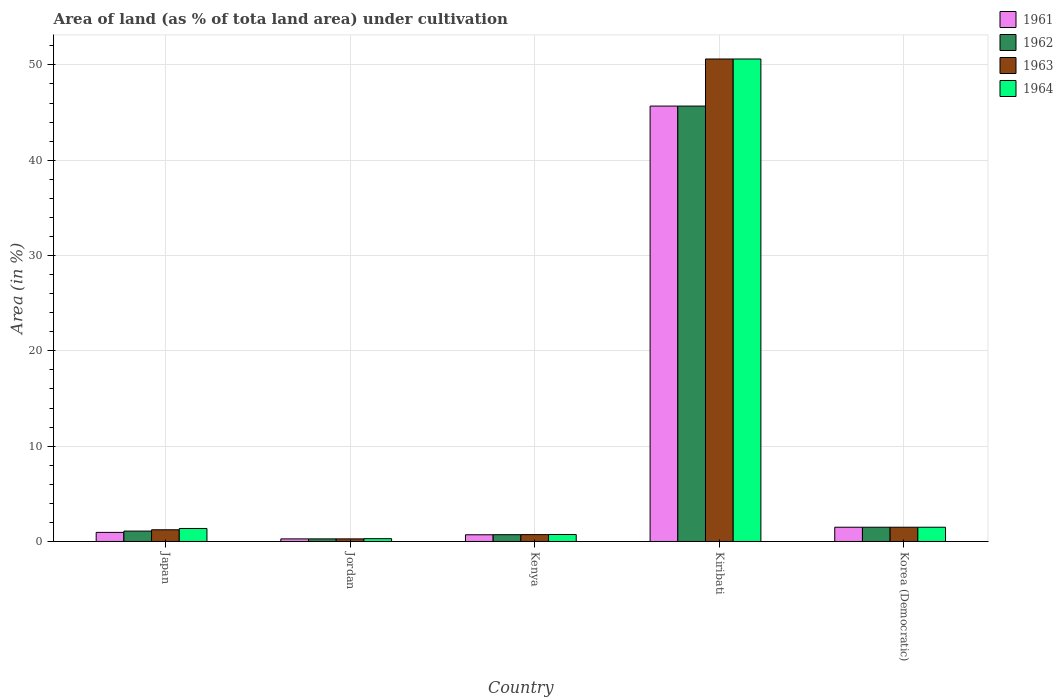How many groups of bars are there?
Your answer should be compact. 5. How many bars are there on the 1st tick from the left?
Your answer should be compact. 4. How many bars are there on the 1st tick from the right?
Your response must be concise. 4. What is the label of the 2nd group of bars from the left?
Ensure brevity in your answer.  Jordan. What is the percentage of land under cultivation in 1961 in Kiribati?
Provide a succinct answer. 45.68. Across all countries, what is the maximum percentage of land under cultivation in 1962?
Ensure brevity in your answer.  45.68. Across all countries, what is the minimum percentage of land under cultivation in 1961?
Keep it short and to the point. 0.27. In which country was the percentage of land under cultivation in 1961 maximum?
Provide a short and direct response. Kiribati. In which country was the percentage of land under cultivation in 1963 minimum?
Make the answer very short. Jordan. What is the total percentage of land under cultivation in 1963 in the graph?
Ensure brevity in your answer.  54.33. What is the difference between the percentage of land under cultivation in 1964 in Kenya and that in Kiribati?
Ensure brevity in your answer.  -49.89. What is the difference between the percentage of land under cultivation in 1961 in Jordan and the percentage of land under cultivation in 1962 in Japan?
Your response must be concise. -0.82. What is the average percentage of land under cultivation in 1964 per country?
Your response must be concise. 10.9. What is the difference between the percentage of land under cultivation of/in 1963 and percentage of land under cultivation of/in 1964 in Japan?
Ensure brevity in your answer.  -0.14. What is the ratio of the percentage of land under cultivation in 1963 in Japan to that in Korea (Democratic)?
Your answer should be compact. 0.82. Is the percentage of land under cultivation in 1961 in Kenya less than that in Korea (Democratic)?
Your answer should be very brief. Yes. Is the difference between the percentage of land under cultivation in 1963 in Japan and Kenya greater than the difference between the percentage of land under cultivation in 1964 in Japan and Kenya?
Your response must be concise. No. What is the difference between the highest and the second highest percentage of land under cultivation in 1961?
Your answer should be compact. -0.54. What is the difference between the highest and the lowest percentage of land under cultivation in 1963?
Your answer should be very brief. 50.35. In how many countries, is the percentage of land under cultivation in 1964 greater than the average percentage of land under cultivation in 1964 taken over all countries?
Ensure brevity in your answer.  1. Is it the case that in every country, the sum of the percentage of land under cultivation in 1964 and percentage of land under cultivation in 1962 is greater than the sum of percentage of land under cultivation in 1963 and percentage of land under cultivation in 1961?
Provide a succinct answer. No. What does the 4th bar from the left in Japan represents?
Provide a succinct answer. 1964. What does the 2nd bar from the right in Jordan represents?
Offer a very short reply. 1963. How many countries are there in the graph?
Offer a terse response. 5. Are the values on the major ticks of Y-axis written in scientific E-notation?
Your answer should be compact. No. Does the graph contain any zero values?
Offer a very short reply. No. Where does the legend appear in the graph?
Provide a short and direct response. Top right. How are the legend labels stacked?
Keep it short and to the point. Vertical. What is the title of the graph?
Keep it short and to the point. Area of land (as % of tota land area) under cultivation. What is the label or title of the X-axis?
Make the answer very short. Country. What is the label or title of the Y-axis?
Ensure brevity in your answer.  Area (in %). What is the Area (in %) in 1961 in Japan?
Your response must be concise. 0.95. What is the Area (in %) in 1962 in Japan?
Ensure brevity in your answer.  1.09. What is the Area (in %) in 1963 in Japan?
Keep it short and to the point. 1.23. What is the Area (in %) of 1964 in Japan?
Your answer should be compact. 1.36. What is the Area (in %) of 1961 in Jordan?
Provide a short and direct response. 0.27. What is the Area (in %) in 1962 in Jordan?
Ensure brevity in your answer.  0.27. What is the Area (in %) of 1963 in Jordan?
Provide a short and direct response. 0.27. What is the Area (in %) of 1964 in Jordan?
Your answer should be very brief. 0.29. What is the Area (in %) in 1961 in Kenya?
Your answer should be very brief. 0.7. What is the Area (in %) in 1962 in Kenya?
Provide a short and direct response. 0.71. What is the Area (in %) in 1963 in Kenya?
Your response must be concise. 0.72. What is the Area (in %) in 1964 in Kenya?
Your response must be concise. 0.73. What is the Area (in %) in 1961 in Kiribati?
Keep it short and to the point. 45.68. What is the Area (in %) in 1962 in Kiribati?
Offer a very short reply. 45.68. What is the Area (in %) of 1963 in Kiribati?
Provide a succinct answer. 50.62. What is the Area (in %) of 1964 in Kiribati?
Provide a succinct answer. 50.62. What is the Area (in %) of 1961 in Korea (Democratic)?
Ensure brevity in your answer.  1.49. What is the Area (in %) of 1962 in Korea (Democratic)?
Make the answer very short. 1.49. What is the Area (in %) of 1963 in Korea (Democratic)?
Keep it short and to the point. 1.49. What is the Area (in %) in 1964 in Korea (Democratic)?
Provide a short and direct response. 1.49. Across all countries, what is the maximum Area (in %) in 1961?
Provide a short and direct response. 45.68. Across all countries, what is the maximum Area (in %) in 1962?
Give a very brief answer. 45.68. Across all countries, what is the maximum Area (in %) of 1963?
Your response must be concise. 50.62. Across all countries, what is the maximum Area (in %) of 1964?
Provide a succinct answer. 50.62. Across all countries, what is the minimum Area (in %) of 1961?
Keep it short and to the point. 0.27. Across all countries, what is the minimum Area (in %) in 1962?
Offer a terse response. 0.27. Across all countries, what is the minimum Area (in %) of 1963?
Your answer should be compact. 0.27. Across all countries, what is the minimum Area (in %) in 1964?
Your response must be concise. 0.29. What is the total Area (in %) of 1961 in the graph?
Give a very brief answer. 49.1. What is the total Area (in %) of 1962 in the graph?
Provide a succinct answer. 49.25. What is the total Area (in %) in 1963 in the graph?
Offer a terse response. 54.33. What is the total Area (in %) of 1964 in the graph?
Keep it short and to the point. 54.5. What is the difference between the Area (in %) of 1961 in Japan and that in Jordan?
Offer a very short reply. 0.68. What is the difference between the Area (in %) in 1962 in Japan and that in Jordan?
Make the answer very short. 0.82. What is the difference between the Area (in %) of 1963 in Japan and that in Jordan?
Offer a very short reply. 0.96. What is the difference between the Area (in %) of 1964 in Japan and that in Jordan?
Provide a succinct answer. 1.07. What is the difference between the Area (in %) in 1961 in Japan and that in Kenya?
Give a very brief answer. 0.25. What is the difference between the Area (in %) in 1962 in Japan and that in Kenya?
Your answer should be compact. 0.38. What is the difference between the Area (in %) in 1963 in Japan and that in Kenya?
Offer a very short reply. 0.51. What is the difference between the Area (in %) of 1964 in Japan and that in Kenya?
Give a very brief answer. 0.63. What is the difference between the Area (in %) in 1961 in Japan and that in Kiribati?
Make the answer very short. -44.72. What is the difference between the Area (in %) in 1962 in Japan and that in Kiribati?
Offer a very short reply. -44.59. What is the difference between the Area (in %) in 1963 in Japan and that in Kiribati?
Make the answer very short. -49.39. What is the difference between the Area (in %) of 1964 in Japan and that in Kiribati?
Ensure brevity in your answer.  -49.25. What is the difference between the Area (in %) in 1961 in Japan and that in Korea (Democratic)?
Make the answer very short. -0.54. What is the difference between the Area (in %) in 1962 in Japan and that in Korea (Democratic)?
Make the answer very short. -0.4. What is the difference between the Area (in %) in 1963 in Japan and that in Korea (Democratic)?
Your answer should be compact. -0.27. What is the difference between the Area (in %) of 1964 in Japan and that in Korea (Democratic)?
Offer a terse response. -0.13. What is the difference between the Area (in %) of 1961 in Jordan and that in Kenya?
Give a very brief answer. -0.43. What is the difference between the Area (in %) in 1962 in Jordan and that in Kenya?
Provide a succinct answer. -0.44. What is the difference between the Area (in %) of 1963 in Jordan and that in Kenya?
Make the answer very short. -0.45. What is the difference between the Area (in %) of 1964 in Jordan and that in Kenya?
Your answer should be compact. -0.43. What is the difference between the Area (in %) of 1961 in Jordan and that in Kiribati?
Make the answer very short. -45.41. What is the difference between the Area (in %) in 1962 in Jordan and that in Kiribati?
Your answer should be compact. -45.41. What is the difference between the Area (in %) in 1963 in Jordan and that in Kiribati?
Give a very brief answer. -50.35. What is the difference between the Area (in %) of 1964 in Jordan and that in Kiribati?
Offer a terse response. -50.32. What is the difference between the Area (in %) in 1961 in Jordan and that in Korea (Democratic)?
Keep it short and to the point. -1.22. What is the difference between the Area (in %) in 1962 in Jordan and that in Korea (Democratic)?
Provide a short and direct response. -1.22. What is the difference between the Area (in %) of 1963 in Jordan and that in Korea (Democratic)?
Provide a short and direct response. -1.22. What is the difference between the Area (in %) in 1964 in Jordan and that in Korea (Democratic)?
Give a very brief answer. -1.2. What is the difference between the Area (in %) of 1961 in Kenya and that in Kiribati?
Offer a very short reply. -44.98. What is the difference between the Area (in %) of 1962 in Kenya and that in Kiribati?
Provide a short and direct response. -44.97. What is the difference between the Area (in %) of 1963 in Kenya and that in Kiribati?
Offer a terse response. -49.9. What is the difference between the Area (in %) of 1964 in Kenya and that in Kiribati?
Make the answer very short. -49.89. What is the difference between the Area (in %) of 1961 in Kenya and that in Korea (Democratic)?
Your answer should be compact. -0.79. What is the difference between the Area (in %) in 1962 in Kenya and that in Korea (Democratic)?
Your answer should be compact. -0.78. What is the difference between the Area (in %) in 1963 in Kenya and that in Korea (Democratic)?
Ensure brevity in your answer.  -0.77. What is the difference between the Area (in %) of 1964 in Kenya and that in Korea (Democratic)?
Provide a short and direct response. -0.77. What is the difference between the Area (in %) of 1961 in Kiribati and that in Korea (Democratic)?
Provide a succinct answer. 44.18. What is the difference between the Area (in %) of 1962 in Kiribati and that in Korea (Democratic)?
Ensure brevity in your answer.  44.18. What is the difference between the Area (in %) in 1963 in Kiribati and that in Korea (Democratic)?
Your answer should be compact. 49.12. What is the difference between the Area (in %) in 1964 in Kiribati and that in Korea (Democratic)?
Your answer should be very brief. 49.12. What is the difference between the Area (in %) in 1961 in Japan and the Area (in %) in 1962 in Jordan?
Offer a very short reply. 0.68. What is the difference between the Area (in %) of 1961 in Japan and the Area (in %) of 1963 in Jordan?
Make the answer very short. 0.68. What is the difference between the Area (in %) in 1961 in Japan and the Area (in %) in 1964 in Jordan?
Give a very brief answer. 0.66. What is the difference between the Area (in %) of 1962 in Japan and the Area (in %) of 1963 in Jordan?
Keep it short and to the point. 0.82. What is the difference between the Area (in %) in 1962 in Japan and the Area (in %) in 1964 in Jordan?
Give a very brief answer. 0.8. What is the difference between the Area (in %) of 1963 in Japan and the Area (in %) of 1964 in Jordan?
Your answer should be very brief. 0.93. What is the difference between the Area (in %) of 1961 in Japan and the Area (in %) of 1962 in Kenya?
Offer a terse response. 0.24. What is the difference between the Area (in %) in 1961 in Japan and the Area (in %) in 1963 in Kenya?
Provide a succinct answer. 0.23. What is the difference between the Area (in %) of 1961 in Japan and the Area (in %) of 1964 in Kenya?
Your answer should be compact. 0.23. What is the difference between the Area (in %) in 1962 in Japan and the Area (in %) in 1963 in Kenya?
Your answer should be very brief. 0.37. What is the difference between the Area (in %) in 1962 in Japan and the Area (in %) in 1964 in Kenya?
Provide a succinct answer. 0.36. What is the difference between the Area (in %) in 1963 in Japan and the Area (in %) in 1964 in Kenya?
Provide a succinct answer. 0.5. What is the difference between the Area (in %) in 1961 in Japan and the Area (in %) in 1962 in Kiribati?
Ensure brevity in your answer.  -44.72. What is the difference between the Area (in %) of 1961 in Japan and the Area (in %) of 1963 in Kiribati?
Provide a short and direct response. -49.66. What is the difference between the Area (in %) of 1961 in Japan and the Area (in %) of 1964 in Kiribati?
Give a very brief answer. -49.66. What is the difference between the Area (in %) in 1962 in Japan and the Area (in %) in 1963 in Kiribati?
Your answer should be very brief. -49.53. What is the difference between the Area (in %) in 1962 in Japan and the Area (in %) in 1964 in Kiribati?
Your answer should be compact. -49.53. What is the difference between the Area (in %) in 1963 in Japan and the Area (in %) in 1964 in Kiribati?
Offer a terse response. -49.39. What is the difference between the Area (in %) of 1961 in Japan and the Area (in %) of 1962 in Korea (Democratic)?
Make the answer very short. -0.54. What is the difference between the Area (in %) in 1961 in Japan and the Area (in %) in 1963 in Korea (Democratic)?
Your response must be concise. -0.54. What is the difference between the Area (in %) of 1961 in Japan and the Area (in %) of 1964 in Korea (Democratic)?
Offer a terse response. -0.54. What is the difference between the Area (in %) of 1962 in Japan and the Area (in %) of 1963 in Korea (Democratic)?
Keep it short and to the point. -0.4. What is the difference between the Area (in %) of 1962 in Japan and the Area (in %) of 1964 in Korea (Democratic)?
Give a very brief answer. -0.4. What is the difference between the Area (in %) in 1963 in Japan and the Area (in %) in 1964 in Korea (Democratic)?
Ensure brevity in your answer.  -0.27. What is the difference between the Area (in %) in 1961 in Jordan and the Area (in %) in 1962 in Kenya?
Offer a terse response. -0.44. What is the difference between the Area (in %) in 1961 in Jordan and the Area (in %) in 1963 in Kenya?
Provide a short and direct response. -0.45. What is the difference between the Area (in %) in 1961 in Jordan and the Area (in %) in 1964 in Kenya?
Provide a short and direct response. -0.46. What is the difference between the Area (in %) of 1962 in Jordan and the Area (in %) of 1963 in Kenya?
Keep it short and to the point. -0.45. What is the difference between the Area (in %) in 1962 in Jordan and the Area (in %) in 1964 in Kenya?
Provide a short and direct response. -0.46. What is the difference between the Area (in %) in 1963 in Jordan and the Area (in %) in 1964 in Kenya?
Your answer should be compact. -0.46. What is the difference between the Area (in %) of 1961 in Jordan and the Area (in %) of 1962 in Kiribati?
Make the answer very short. -45.41. What is the difference between the Area (in %) of 1961 in Jordan and the Area (in %) of 1963 in Kiribati?
Your response must be concise. -50.35. What is the difference between the Area (in %) of 1961 in Jordan and the Area (in %) of 1964 in Kiribati?
Offer a terse response. -50.35. What is the difference between the Area (in %) of 1962 in Jordan and the Area (in %) of 1963 in Kiribati?
Offer a very short reply. -50.35. What is the difference between the Area (in %) in 1962 in Jordan and the Area (in %) in 1964 in Kiribati?
Provide a succinct answer. -50.35. What is the difference between the Area (in %) in 1963 in Jordan and the Area (in %) in 1964 in Kiribati?
Your answer should be very brief. -50.35. What is the difference between the Area (in %) of 1961 in Jordan and the Area (in %) of 1962 in Korea (Democratic)?
Offer a terse response. -1.22. What is the difference between the Area (in %) in 1961 in Jordan and the Area (in %) in 1963 in Korea (Democratic)?
Your answer should be very brief. -1.22. What is the difference between the Area (in %) in 1961 in Jordan and the Area (in %) in 1964 in Korea (Democratic)?
Provide a succinct answer. -1.22. What is the difference between the Area (in %) of 1962 in Jordan and the Area (in %) of 1963 in Korea (Democratic)?
Give a very brief answer. -1.22. What is the difference between the Area (in %) of 1962 in Jordan and the Area (in %) of 1964 in Korea (Democratic)?
Give a very brief answer. -1.22. What is the difference between the Area (in %) in 1963 in Jordan and the Area (in %) in 1964 in Korea (Democratic)?
Offer a very short reply. -1.22. What is the difference between the Area (in %) of 1961 in Kenya and the Area (in %) of 1962 in Kiribati?
Offer a very short reply. -44.98. What is the difference between the Area (in %) of 1961 in Kenya and the Area (in %) of 1963 in Kiribati?
Your answer should be very brief. -49.91. What is the difference between the Area (in %) in 1961 in Kenya and the Area (in %) in 1964 in Kiribati?
Give a very brief answer. -49.91. What is the difference between the Area (in %) in 1962 in Kenya and the Area (in %) in 1963 in Kiribati?
Your answer should be compact. -49.91. What is the difference between the Area (in %) of 1962 in Kenya and the Area (in %) of 1964 in Kiribati?
Your answer should be compact. -49.91. What is the difference between the Area (in %) of 1963 in Kenya and the Area (in %) of 1964 in Kiribati?
Keep it short and to the point. -49.9. What is the difference between the Area (in %) of 1961 in Kenya and the Area (in %) of 1962 in Korea (Democratic)?
Give a very brief answer. -0.79. What is the difference between the Area (in %) of 1961 in Kenya and the Area (in %) of 1963 in Korea (Democratic)?
Offer a very short reply. -0.79. What is the difference between the Area (in %) of 1961 in Kenya and the Area (in %) of 1964 in Korea (Democratic)?
Your response must be concise. -0.79. What is the difference between the Area (in %) of 1962 in Kenya and the Area (in %) of 1963 in Korea (Democratic)?
Your answer should be very brief. -0.78. What is the difference between the Area (in %) of 1962 in Kenya and the Area (in %) of 1964 in Korea (Democratic)?
Your answer should be very brief. -0.78. What is the difference between the Area (in %) in 1963 in Kenya and the Area (in %) in 1964 in Korea (Democratic)?
Provide a short and direct response. -0.77. What is the difference between the Area (in %) of 1961 in Kiribati and the Area (in %) of 1962 in Korea (Democratic)?
Keep it short and to the point. 44.18. What is the difference between the Area (in %) in 1961 in Kiribati and the Area (in %) in 1963 in Korea (Democratic)?
Give a very brief answer. 44.18. What is the difference between the Area (in %) of 1961 in Kiribati and the Area (in %) of 1964 in Korea (Democratic)?
Your answer should be very brief. 44.18. What is the difference between the Area (in %) in 1962 in Kiribati and the Area (in %) in 1963 in Korea (Democratic)?
Give a very brief answer. 44.18. What is the difference between the Area (in %) of 1962 in Kiribati and the Area (in %) of 1964 in Korea (Democratic)?
Offer a terse response. 44.18. What is the difference between the Area (in %) in 1963 in Kiribati and the Area (in %) in 1964 in Korea (Democratic)?
Provide a short and direct response. 49.12. What is the average Area (in %) in 1961 per country?
Ensure brevity in your answer.  9.82. What is the average Area (in %) in 1962 per country?
Provide a succinct answer. 9.85. What is the average Area (in %) in 1963 per country?
Your answer should be compact. 10.87. What is the average Area (in %) in 1964 per country?
Ensure brevity in your answer.  10.9. What is the difference between the Area (in %) in 1961 and Area (in %) in 1962 in Japan?
Make the answer very short. -0.14. What is the difference between the Area (in %) in 1961 and Area (in %) in 1963 in Japan?
Keep it short and to the point. -0.27. What is the difference between the Area (in %) of 1961 and Area (in %) of 1964 in Japan?
Keep it short and to the point. -0.41. What is the difference between the Area (in %) in 1962 and Area (in %) in 1963 in Japan?
Ensure brevity in your answer.  -0.14. What is the difference between the Area (in %) of 1962 and Area (in %) of 1964 in Japan?
Offer a very short reply. -0.27. What is the difference between the Area (in %) in 1963 and Area (in %) in 1964 in Japan?
Keep it short and to the point. -0.14. What is the difference between the Area (in %) in 1961 and Area (in %) in 1964 in Jordan?
Your answer should be compact. -0.02. What is the difference between the Area (in %) of 1962 and Area (in %) of 1964 in Jordan?
Give a very brief answer. -0.02. What is the difference between the Area (in %) of 1963 and Area (in %) of 1964 in Jordan?
Give a very brief answer. -0.02. What is the difference between the Area (in %) in 1961 and Area (in %) in 1962 in Kenya?
Your response must be concise. -0.01. What is the difference between the Area (in %) of 1961 and Area (in %) of 1963 in Kenya?
Offer a terse response. -0.02. What is the difference between the Area (in %) in 1961 and Area (in %) in 1964 in Kenya?
Provide a short and direct response. -0.03. What is the difference between the Area (in %) in 1962 and Area (in %) in 1963 in Kenya?
Offer a terse response. -0.01. What is the difference between the Area (in %) of 1962 and Area (in %) of 1964 in Kenya?
Make the answer very short. -0.02. What is the difference between the Area (in %) of 1963 and Area (in %) of 1964 in Kenya?
Your answer should be very brief. -0.01. What is the difference between the Area (in %) of 1961 and Area (in %) of 1963 in Kiribati?
Offer a terse response. -4.94. What is the difference between the Area (in %) of 1961 and Area (in %) of 1964 in Kiribati?
Your answer should be very brief. -4.94. What is the difference between the Area (in %) of 1962 and Area (in %) of 1963 in Kiribati?
Give a very brief answer. -4.94. What is the difference between the Area (in %) of 1962 and Area (in %) of 1964 in Kiribati?
Your answer should be compact. -4.94. What is the difference between the Area (in %) of 1961 and Area (in %) of 1962 in Korea (Democratic)?
Your response must be concise. 0. What is the difference between the Area (in %) in 1961 and Area (in %) in 1963 in Korea (Democratic)?
Provide a succinct answer. 0. What is the difference between the Area (in %) in 1963 and Area (in %) in 1964 in Korea (Democratic)?
Offer a terse response. 0. What is the ratio of the Area (in %) of 1961 in Japan to that in Jordan?
Offer a very short reply. 3.51. What is the ratio of the Area (in %) in 1962 in Japan to that in Jordan?
Provide a succinct answer. 4.01. What is the ratio of the Area (in %) of 1963 in Japan to that in Jordan?
Provide a succinct answer. 4.51. What is the ratio of the Area (in %) of 1964 in Japan to that in Jordan?
Make the answer very short. 4.63. What is the ratio of the Area (in %) of 1961 in Japan to that in Kenya?
Make the answer very short. 1.36. What is the ratio of the Area (in %) of 1962 in Japan to that in Kenya?
Your answer should be very brief. 1.53. What is the ratio of the Area (in %) of 1963 in Japan to that in Kenya?
Ensure brevity in your answer.  1.7. What is the ratio of the Area (in %) of 1964 in Japan to that in Kenya?
Offer a terse response. 1.87. What is the ratio of the Area (in %) in 1961 in Japan to that in Kiribati?
Offer a terse response. 0.02. What is the ratio of the Area (in %) of 1962 in Japan to that in Kiribati?
Make the answer very short. 0.02. What is the ratio of the Area (in %) in 1963 in Japan to that in Kiribati?
Ensure brevity in your answer.  0.02. What is the ratio of the Area (in %) of 1964 in Japan to that in Kiribati?
Make the answer very short. 0.03. What is the ratio of the Area (in %) of 1961 in Japan to that in Korea (Democratic)?
Offer a very short reply. 0.64. What is the ratio of the Area (in %) of 1962 in Japan to that in Korea (Democratic)?
Provide a short and direct response. 0.73. What is the ratio of the Area (in %) in 1963 in Japan to that in Korea (Democratic)?
Offer a very short reply. 0.82. What is the ratio of the Area (in %) in 1964 in Japan to that in Korea (Democratic)?
Your response must be concise. 0.91. What is the ratio of the Area (in %) in 1961 in Jordan to that in Kenya?
Give a very brief answer. 0.39. What is the ratio of the Area (in %) of 1962 in Jordan to that in Kenya?
Provide a succinct answer. 0.38. What is the ratio of the Area (in %) in 1963 in Jordan to that in Kenya?
Make the answer very short. 0.38. What is the ratio of the Area (in %) in 1964 in Jordan to that in Kenya?
Your response must be concise. 0.4. What is the ratio of the Area (in %) in 1961 in Jordan to that in Kiribati?
Offer a very short reply. 0.01. What is the ratio of the Area (in %) of 1962 in Jordan to that in Kiribati?
Keep it short and to the point. 0.01. What is the ratio of the Area (in %) in 1963 in Jordan to that in Kiribati?
Provide a succinct answer. 0.01. What is the ratio of the Area (in %) in 1964 in Jordan to that in Kiribati?
Provide a succinct answer. 0.01. What is the ratio of the Area (in %) in 1961 in Jordan to that in Korea (Democratic)?
Offer a very short reply. 0.18. What is the ratio of the Area (in %) of 1962 in Jordan to that in Korea (Democratic)?
Your answer should be compact. 0.18. What is the ratio of the Area (in %) in 1963 in Jordan to that in Korea (Democratic)?
Provide a short and direct response. 0.18. What is the ratio of the Area (in %) of 1964 in Jordan to that in Korea (Democratic)?
Make the answer very short. 0.2. What is the ratio of the Area (in %) of 1961 in Kenya to that in Kiribati?
Offer a terse response. 0.02. What is the ratio of the Area (in %) in 1962 in Kenya to that in Kiribati?
Offer a very short reply. 0.02. What is the ratio of the Area (in %) in 1963 in Kenya to that in Kiribati?
Provide a short and direct response. 0.01. What is the ratio of the Area (in %) of 1964 in Kenya to that in Kiribati?
Give a very brief answer. 0.01. What is the ratio of the Area (in %) in 1961 in Kenya to that in Korea (Democratic)?
Offer a very short reply. 0.47. What is the ratio of the Area (in %) in 1962 in Kenya to that in Korea (Democratic)?
Your answer should be very brief. 0.48. What is the ratio of the Area (in %) of 1963 in Kenya to that in Korea (Democratic)?
Make the answer very short. 0.48. What is the ratio of the Area (in %) in 1964 in Kenya to that in Korea (Democratic)?
Offer a terse response. 0.49. What is the ratio of the Area (in %) of 1961 in Kiribati to that in Korea (Democratic)?
Give a very brief answer. 30.56. What is the ratio of the Area (in %) of 1962 in Kiribati to that in Korea (Democratic)?
Your response must be concise. 30.56. What is the ratio of the Area (in %) of 1963 in Kiribati to that in Korea (Democratic)?
Offer a terse response. 33.86. What is the ratio of the Area (in %) of 1964 in Kiribati to that in Korea (Democratic)?
Your answer should be compact. 33.86. What is the difference between the highest and the second highest Area (in %) in 1961?
Ensure brevity in your answer.  44.18. What is the difference between the highest and the second highest Area (in %) in 1962?
Offer a very short reply. 44.18. What is the difference between the highest and the second highest Area (in %) of 1963?
Offer a very short reply. 49.12. What is the difference between the highest and the second highest Area (in %) of 1964?
Keep it short and to the point. 49.12. What is the difference between the highest and the lowest Area (in %) in 1961?
Provide a succinct answer. 45.41. What is the difference between the highest and the lowest Area (in %) in 1962?
Offer a terse response. 45.41. What is the difference between the highest and the lowest Area (in %) in 1963?
Your response must be concise. 50.35. What is the difference between the highest and the lowest Area (in %) in 1964?
Provide a succinct answer. 50.32. 